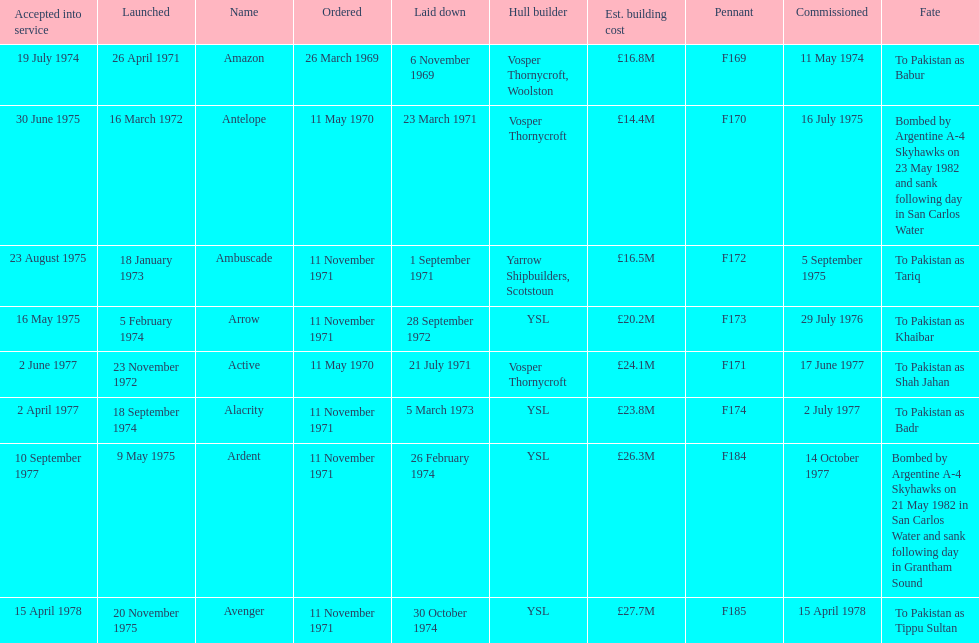What is the name of the ship listed after ardent? Avenger. 